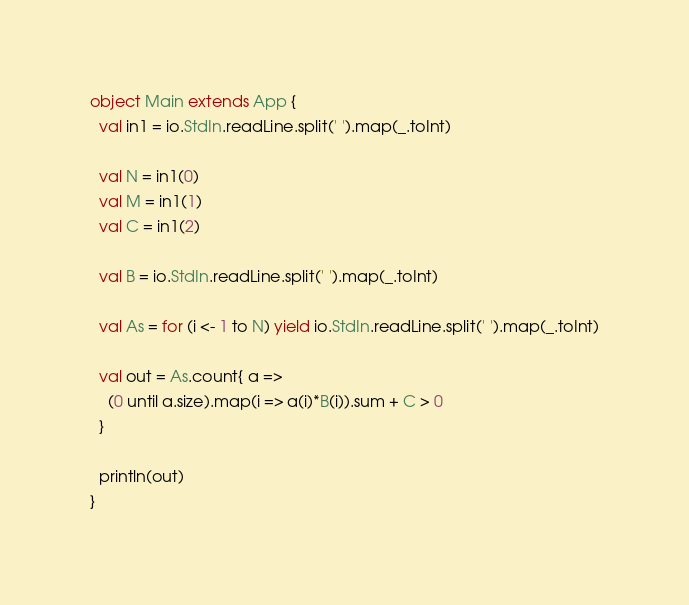<code> <loc_0><loc_0><loc_500><loc_500><_Scala_>object Main extends App {
  val in1 = io.StdIn.readLine.split(' ').map(_.toInt)

  val N = in1(0)
  val M = in1(1)
  val C = in1(2)

  val B = io.StdIn.readLine.split(' ').map(_.toInt)

  val As = for (i <- 1 to N) yield io.StdIn.readLine.split(' ').map(_.toInt)

  val out = As.count{ a =>
    (0 until a.size).map(i => a(i)*B(i)).sum + C > 0
  }

  println(out)
}

</code> 